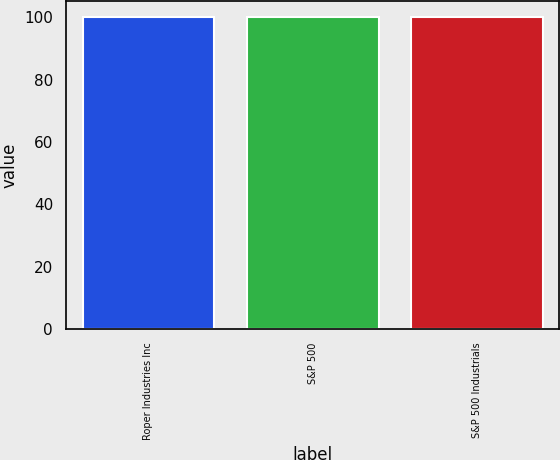<chart> <loc_0><loc_0><loc_500><loc_500><bar_chart><fcel>Roper Industries Inc<fcel>S&P 500<fcel>S&P 500 Industrials<nl><fcel>100<fcel>100.1<fcel>100.2<nl></chart> 